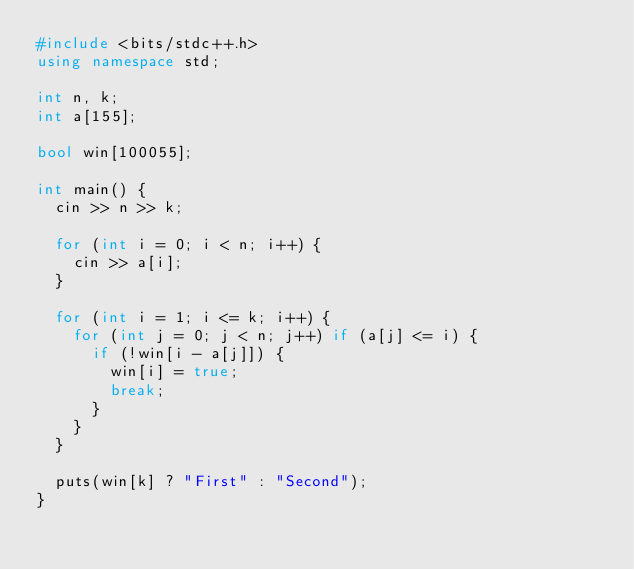Convert code to text. <code><loc_0><loc_0><loc_500><loc_500><_C++_>#include <bits/stdc++.h>
using namespace std;

int n, k;
int a[155];

bool win[100055];

int main() {
	cin >> n >> k;
	
	for (int i = 0; i < n; i++) {
		cin >> a[i];
	}
	
	for (int i = 1; i <= k; i++) {
		for (int j = 0; j < n; j++) if (a[j] <= i) {
			if (!win[i - a[j]]) {
				win[i] = true;
				break;
			}
		}
	}
	
	puts(win[k] ? "First" : "Second");
}
</code> 